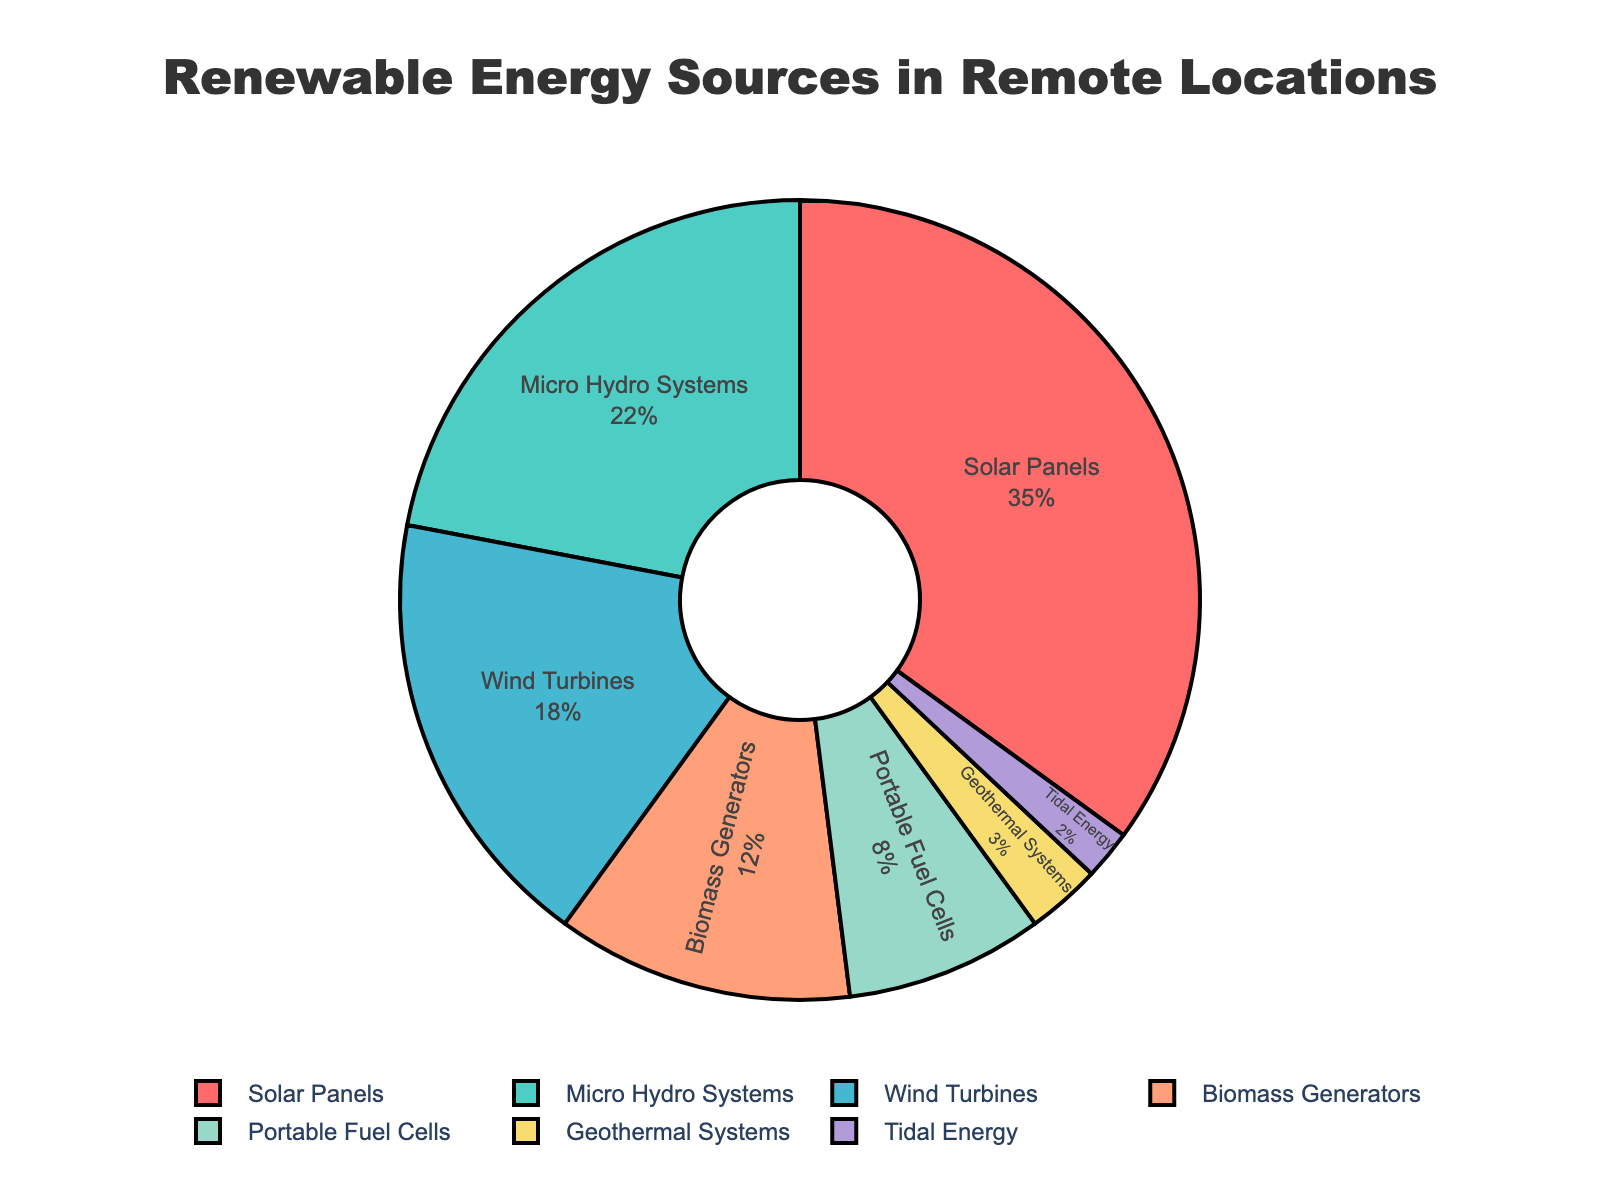What percentage of the total renewable energy sources are represented by Solar Panels and Micro Hydro Systems combined? To get the combined percentage of Solar Panels and Micro Hydro Systems, we add their individual percentages: 35% (Solar Panels) + 22% (Micro Hydro Systems) = 57%
Answer: 57 Which energy source is represented by the smallest percentage? By looking at the pie chart, the energy source with the smallest segment is Tidal Energy, which represents 2%.
Answer: Tidal Energy Is the percentage of Biomass Generators greater than that of Portable Fuel Cells and Geothermal Systems combined? We add the percentages of Portable Fuel Cells and Geothermal Systems: 8% (Portable Fuel Cells) + 3% (Geothermal Systems) = 11%. Biomass Generators have a percentage of 12%, which is greater than 11%.
Answer: Yes Which energy sources have a smaller combined percentage than Solar Panels? Compare the sum of other sources to 35% (Solar Panels). Micro Hydro Systems (22%), Wind Turbines (18%), Biomass Generators (12%), Portable Fuel Cells (8%), Geothermal Systems (3%), and Tidal Energy (2%) individually are all smaller than Solar Panels. However, only Tidal Energy has a smaller combined percentage (2%).
Answer: Tidal Energy Which energy source is represented by a light green color in the chart? Referring to the chart, the renewable energy source represented by the light green color is Micro Hydro Systems.
Answer: Micro Hydro Systems What is the combined percentage of Wind Turbines and Geothermal Systems? Add the percentages of Wind Turbines and Geothermal Systems: 18% (Wind Turbines) + 3% (Geothermal Systems) = 21%
Answer: 21 Describe the shaded segment of color with the highest percentage? The largest shaded segment in the pie chart, represented by a red color, corresponds to Solar Panels with a percentage of 35%.
Answer: Solar Panels at 35% Could you provide the percentage difference between Wind Turbines and Biomass Generators? Calculate the difference between Wind Turbines (18%) and Biomass Generators (12%): 18% - 12% = 6%
Answer: 6 